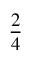<formula> <loc_0><loc_0><loc_500><loc_500>\frac { 2 } { 4 }</formula> 